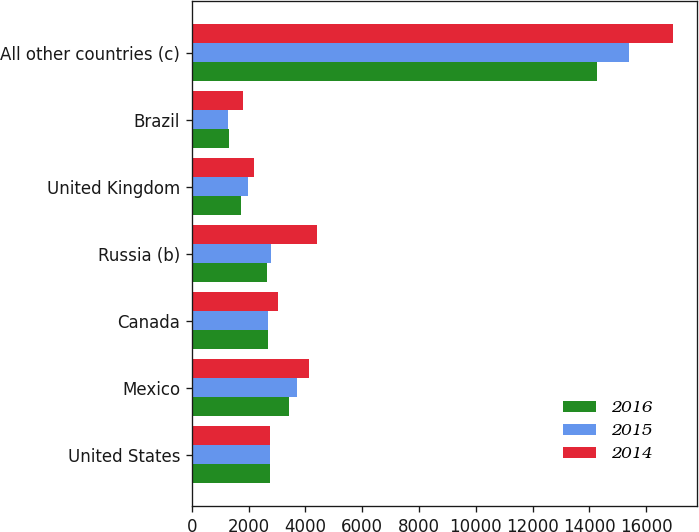<chart> <loc_0><loc_0><loc_500><loc_500><stacked_bar_chart><ecel><fcel>United States<fcel>Mexico<fcel>Canada<fcel>Russia (b)<fcel>United Kingdom<fcel>Brazil<fcel>All other countries (c)<nl><fcel>2016<fcel>2744.5<fcel>3431<fcel>2692<fcel>2648<fcel>1737<fcel>1305<fcel>14254<nl><fcel>2015<fcel>2744.5<fcel>3687<fcel>2677<fcel>2797<fcel>1966<fcel>1289<fcel>15374<nl><fcel>2014<fcel>2744.5<fcel>4113<fcel>3022<fcel>4414<fcel>2174<fcel>1790<fcel>16951<nl></chart> 